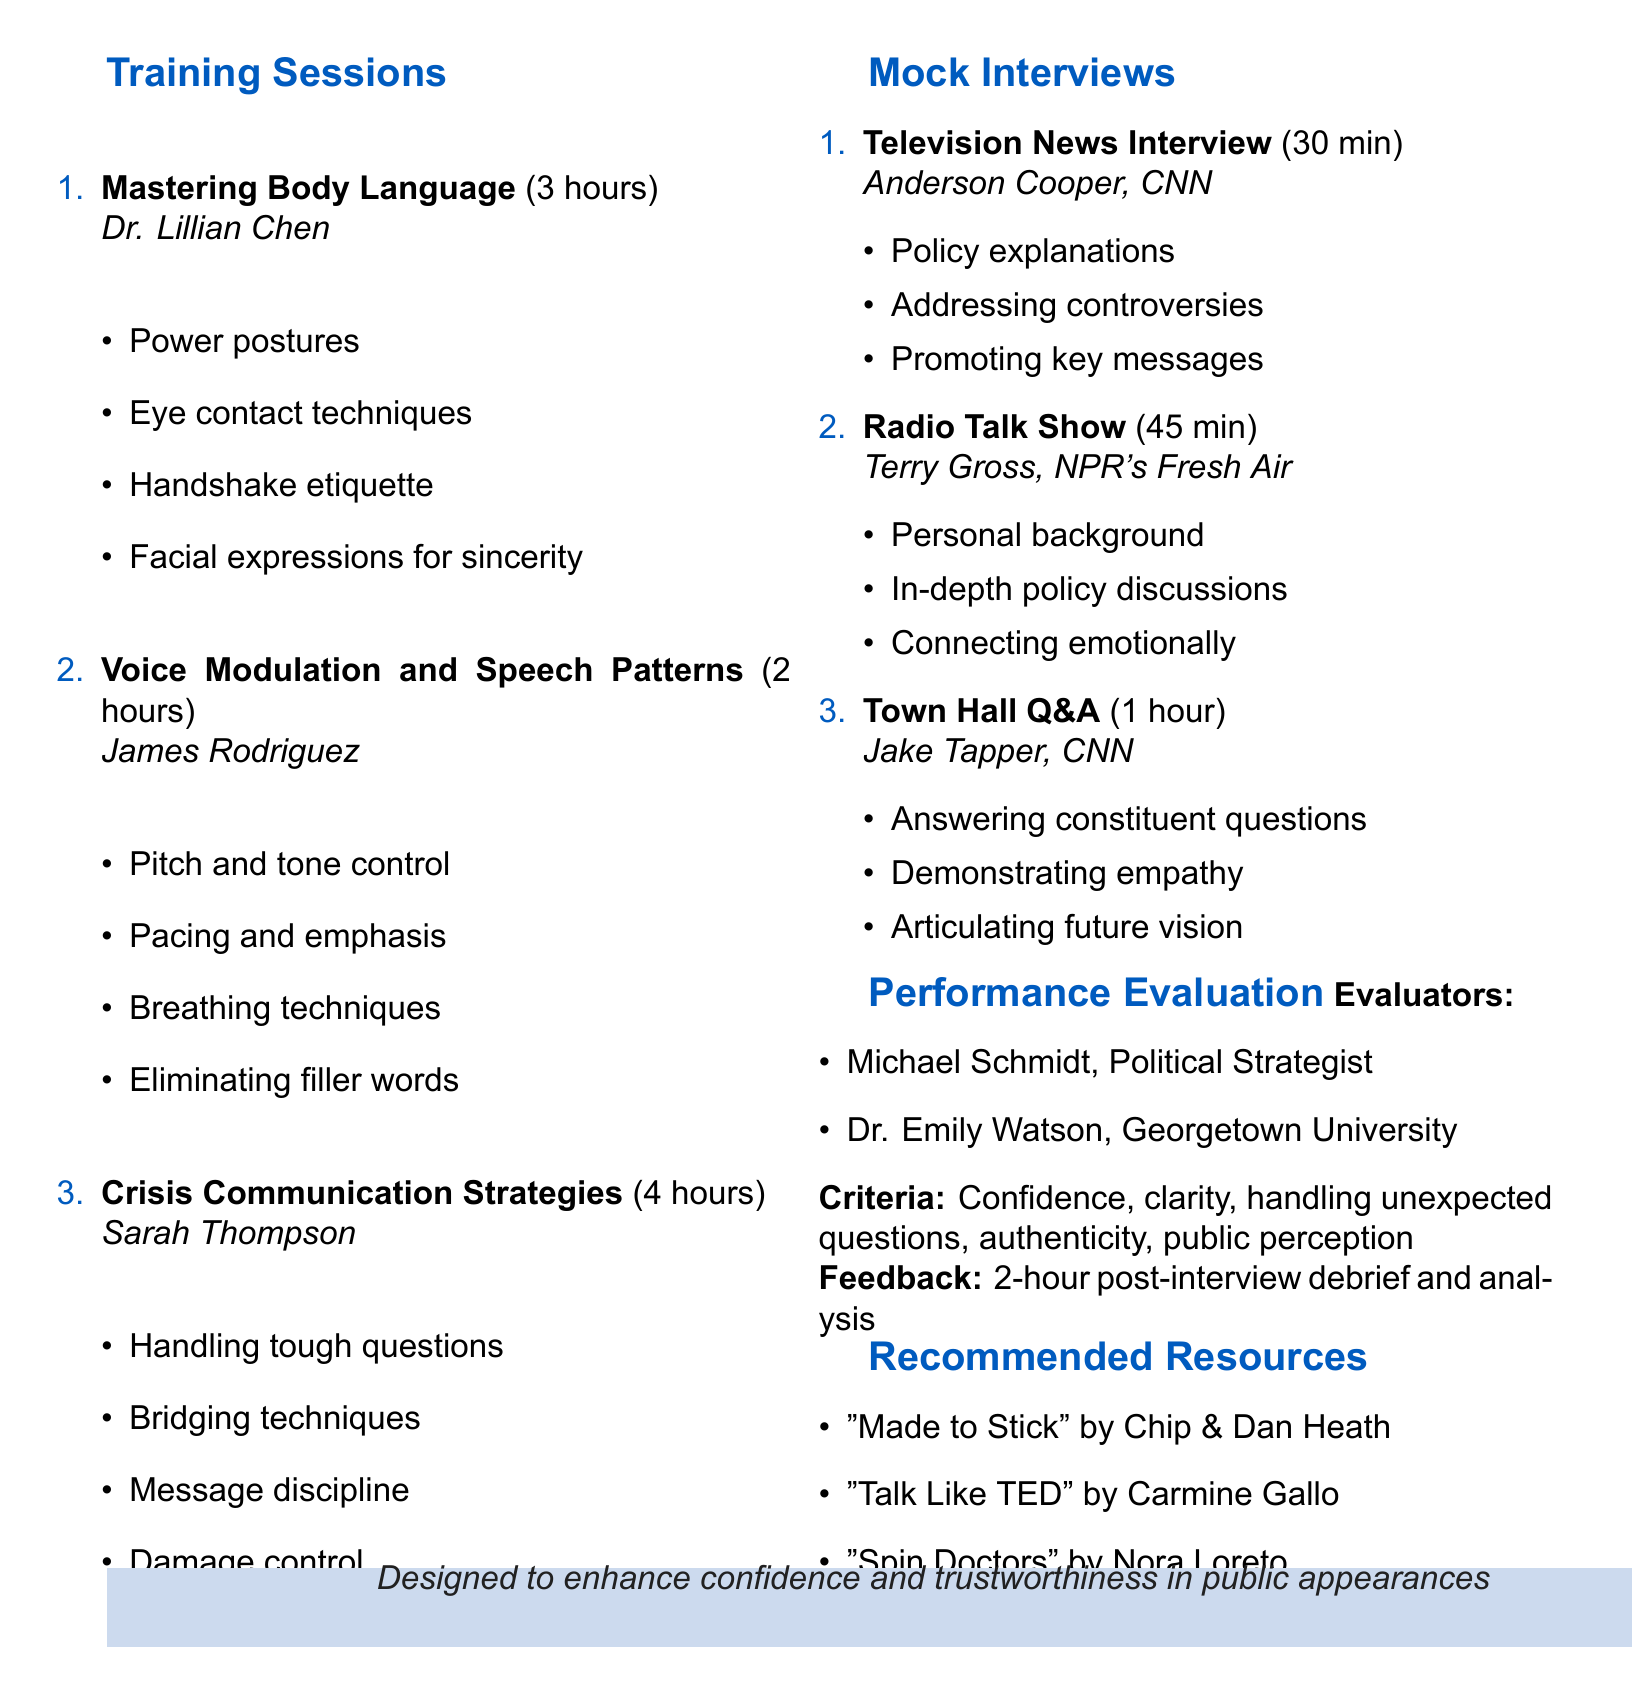What is the title of the agenda? The title of the agenda is explicitly stated at the beginning of the document, which is "Media Training and Mock Interview Schedule for Improved Public Speaking."
Answer: Media Training and Mock Interview Schedule for Improved Public Speaking Who is the instructor for the "Crisis Communication Strategies" session? The instructor for this session is mentioned in the section detailing the training sessions, which lists "Sarah Thompson" as the instructor.
Answer: Sarah Thompson How long is the "Voice Modulation and Speech Patterns" session? The duration of this session is specified in the training sessions section, indicating that it lasts for "2 hours."
Answer: 2 hours What is one of the focus areas for the Television News Interview? The focus areas for this interview type are listed, and one of them is "Policy explanations."
Answer: Policy explanations Who will evaluate the performance during the sessions? The evaluators are named in the performance evaluation section, specifying "Michael Schmidt" and "Dr. Emily Watson."
Answer: Michael Schmidt, Dr. Emily Watson Which book is recommended for crafting memorable messages? The recommended resources section lists a book that addresses this topic, specifically "Made to Stick: Why Some Ideas Survive and Others Die."
Answer: Made to Stick: Why Some Ideas Survive and Others Die What is the duration of the Town Hall Q&A mock interview? The duration for this specific interview type is stated in the document, indicating that it lasts "1 hour."
Answer: 1 hour What is one criterion for performance evaluation? The evaluation criteria are listed, with "Confidence level" as one example among others.
Answer: Confidence level What type of mock interview lasts for 45 minutes? The document states that the "Radio Talk Show" mock interview lasts for this duration.
Answer: Radio Talk Show 